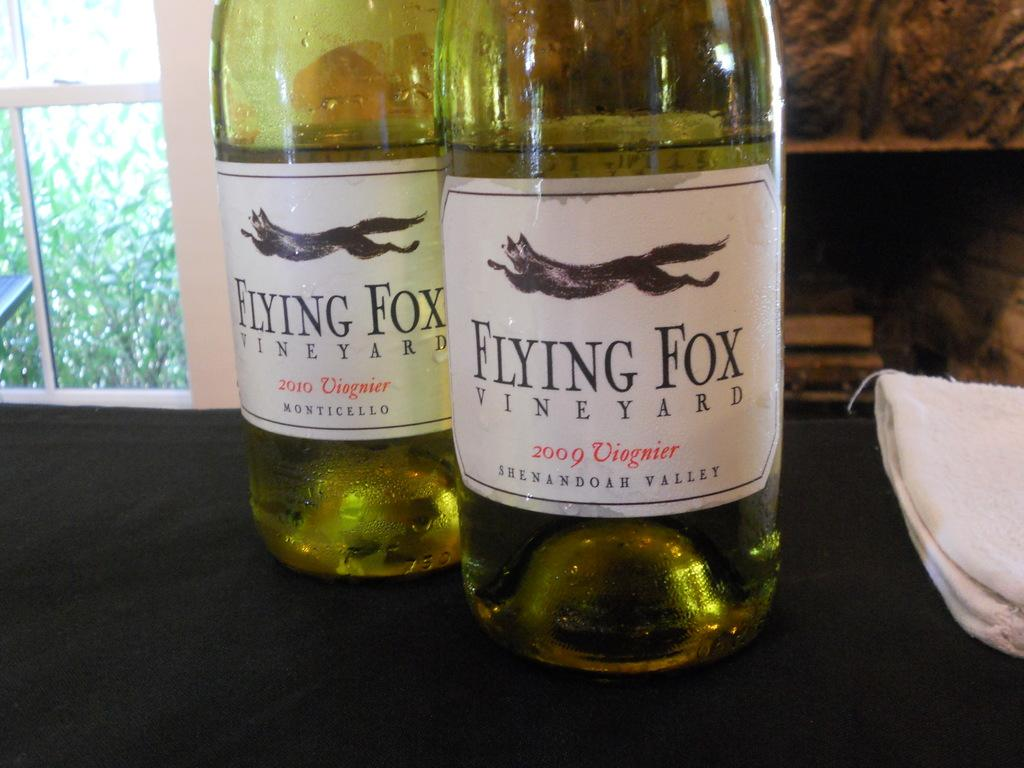What type of furniture is present in the image? There is a table in the image. What is the color of the table? The table is black in color. What objects are on the table? There are two glass bottles on the table. What is written on the glass bottles? The glass bottles have "flying fox" written on them. What type of show is the flying fox performing in the image? There is no flying fox performing a show in the image; the glass bottles have "flying fox" written on them, but it is not related to a live performance. 